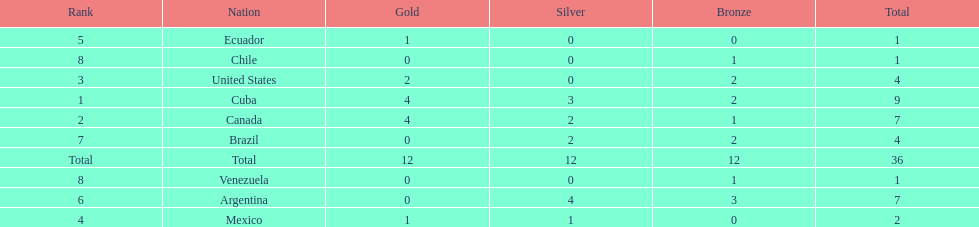How many total medals did brazil received? 4. 